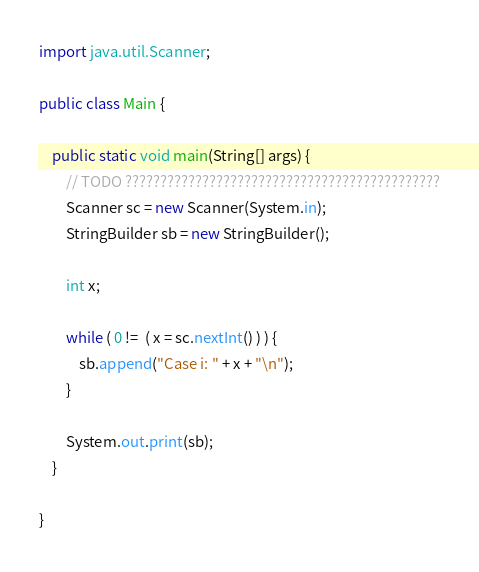<code> <loc_0><loc_0><loc_500><loc_500><_Java_>import java.util.Scanner;

public class Main {

	public static void main(String[] args) {
		// TODO ?????????????????????????????????????????????
		Scanner sc = new Scanner(System.in);
		StringBuilder sb = new StringBuilder();

		int x;

		while ( 0 !=  ( x = sc.nextInt() ) ) {
			sb.append("Case i: " + x + "\n");
		}

		System.out.print(sb);
	}

}</code> 